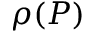<formula> <loc_0><loc_0><loc_500><loc_500>\rho ( P )</formula> 